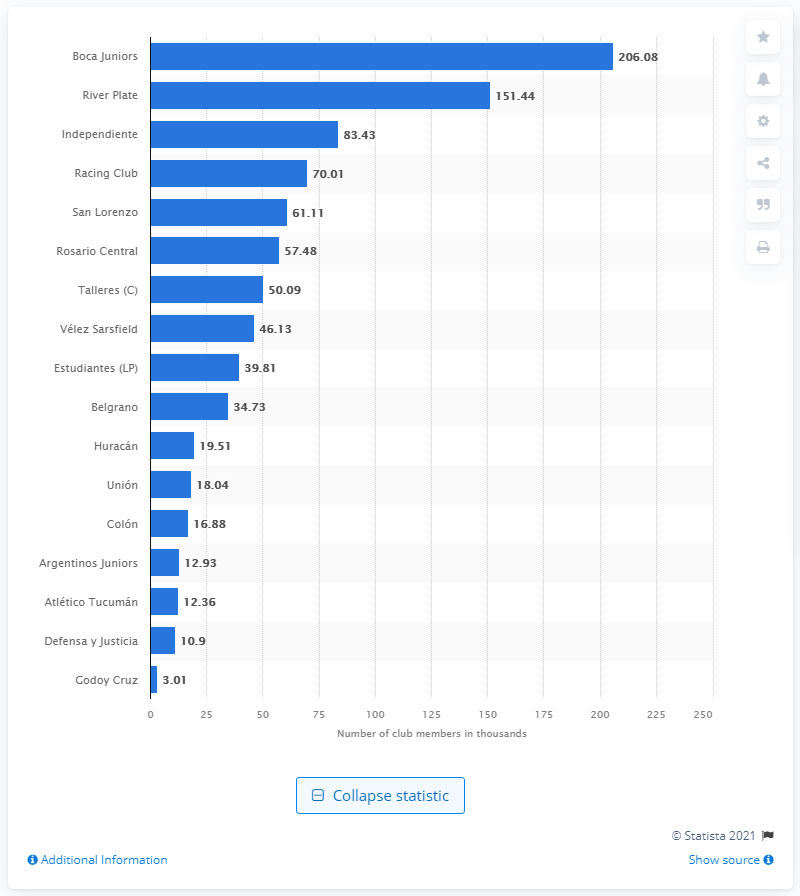Identify some key points in this picture. Boca Juniors is the soccer club with the highest number of fan members in the Superliga. 